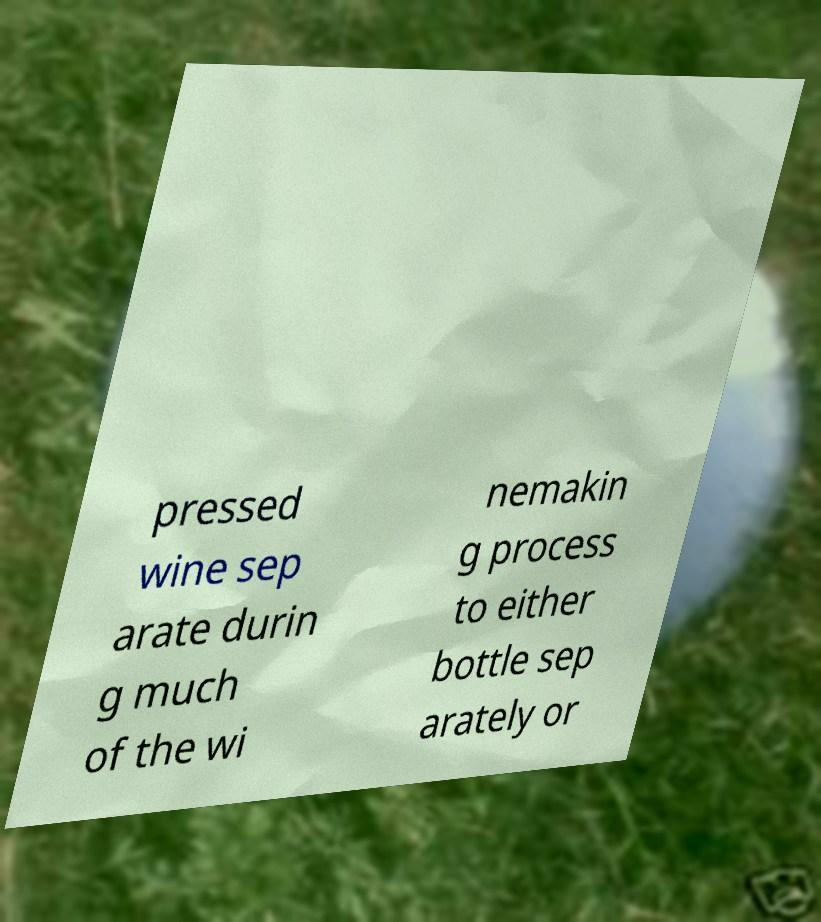Can you read and provide the text displayed in the image?This photo seems to have some interesting text. Can you extract and type it out for me? pressed wine sep arate durin g much of the wi nemakin g process to either bottle sep arately or 